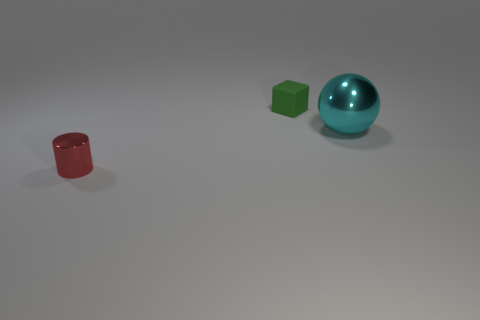How many things are large yellow matte balls or shiny things?
Ensure brevity in your answer.  2. There is a metal object that is behind the tiny metal cylinder that is left of the tiny green thing; how many green objects are behind it?
Offer a terse response. 1. There is a thing that is on the right side of the small red cylinder and on the left side of the big sphere; what material is it made of?
Ensure brevity in your answer.  Rubber. Are there fewer small green matte blocks left of the tiny red metallic cylinder than small cylinders in front of the green cube?
Offer a terse response. Yes. How many other things are there of the same size as the red cylinder?
Your answer should be very brief. 1. What is the shape of the object that is to the right of the small object right of the object on the left side of the green block?
Keep it short and to the point. Sphere. What number of yellow things are tiny matte objects or tiny cylinders?
Your response must be concise. 0. What number of tiny things are in front of the metal thing right of the small shiny thing?
Make the answer very short. 1. Is there any other thing that has the same color as the tiny metal object?
Provide a short and direct response. No. What is the shape of the red object that is the same material as the ball?
Ensure brevity in your answer.  Cylinder. 